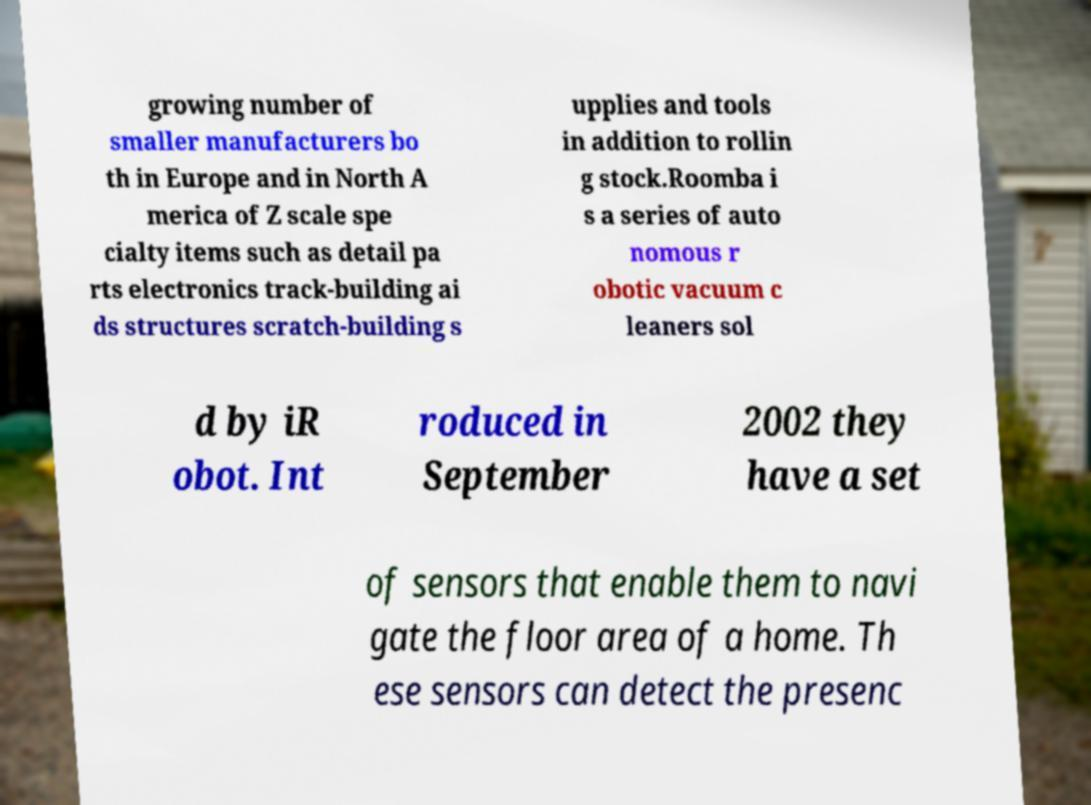For documentation purposes, I need the text within this image transcribed. Could you provide that? growing number of smaller manufacturers bo th in Europe and in North A merica of Z scale spe cialty items such as detail pa rts electronics track-building ai ds structures scratch-building s upplies and tools in addition to rollin g stock.Roomba i s a series of auto nomous r obotic vacuum c leaners sol d by iR obot. Int roduced in September 2002 they have a set of sensors that enable them to navi gate the floor area of a home. Th ese sensors can detect the presenc 